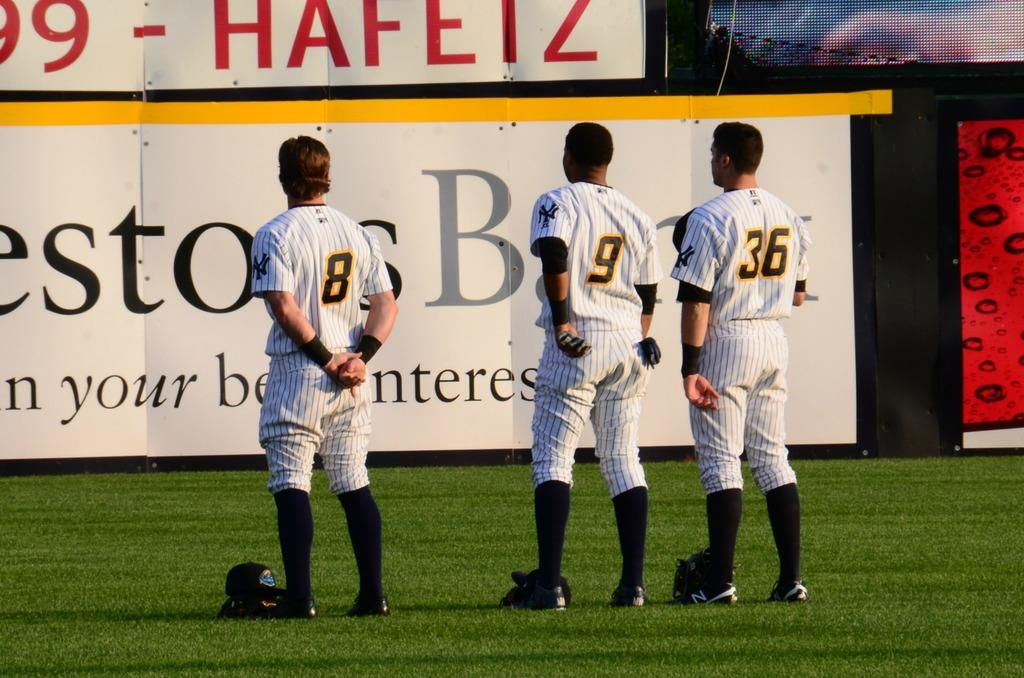<image>
Share a concise interpretation of the image provided. Players 8, 9, and 36 stand on the green field 